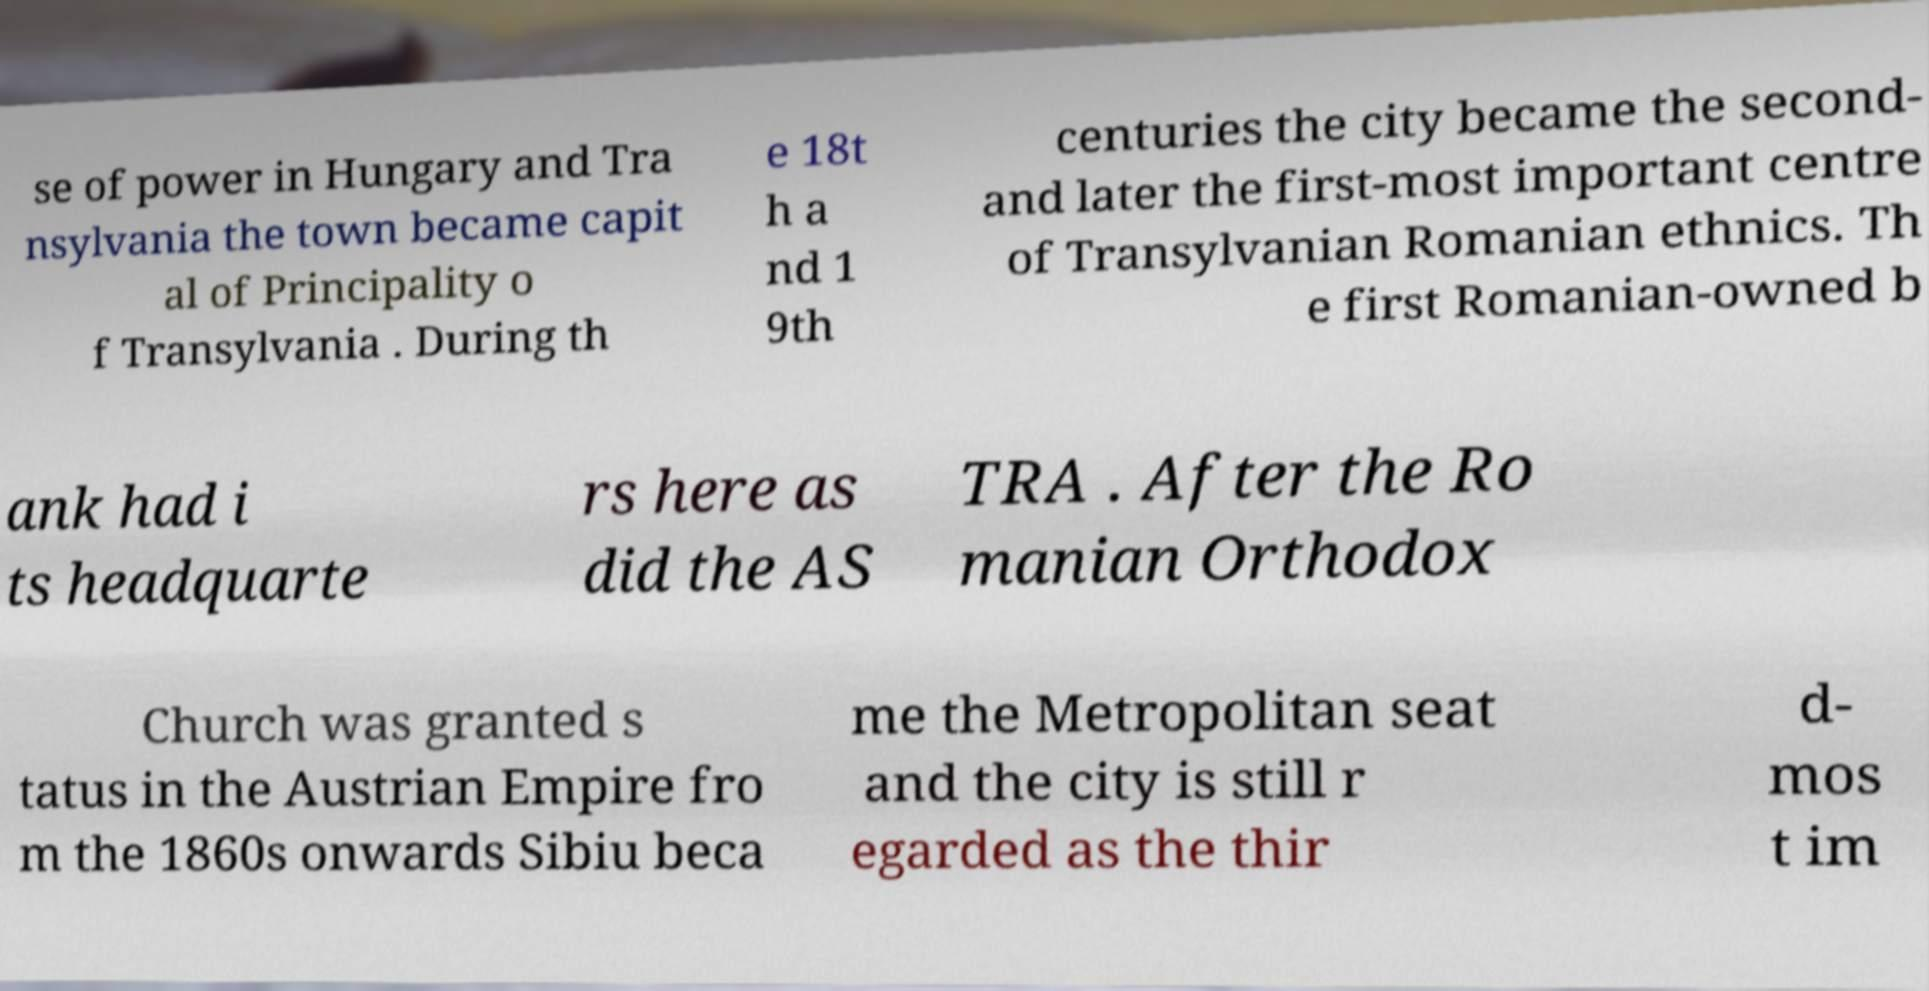Please read and relay the text visible in this image. What does it say? se of power in Hungary and Tra nsylvania the town became capit al of Principality o f Transylvania . During th e 18t h a nd 1 9th centuries the city became the second- and later the first-most important centre of Transylvanian Romanian ethnics. Th e first Romanian-owned b ank had i ts headquarte rs here as did the AS TRA . After the Ro manian Orthodox Church was granted s tatus in the Austrian Empire fro m the 1860s onwards Sibiu beca me the Metropolitan seat and the city is still r egarded as the thir d- mos t im 